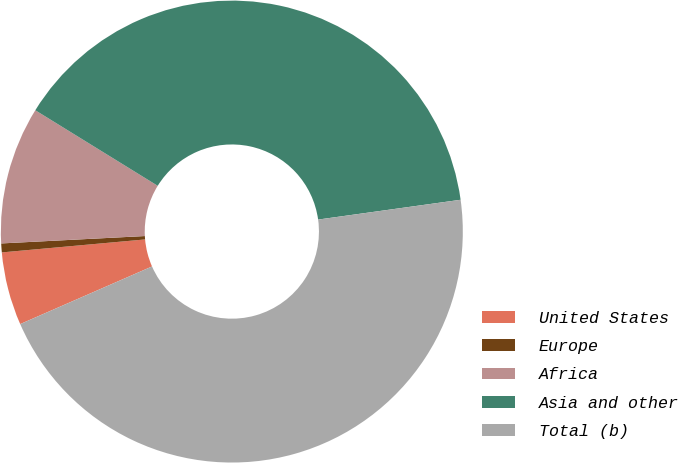<chart> <loc_0><loc_0><loc_500><loc_500><pie_chart><fcel>United States<fcel>Europe<fcel>Africa<fcel>Asia and other<fcel>Total (b)<nl><fcel>5.12%<fcel>0.62%<fcel>9.62%<fcel>39.0%<fcel>45.64%<nl></chart> 